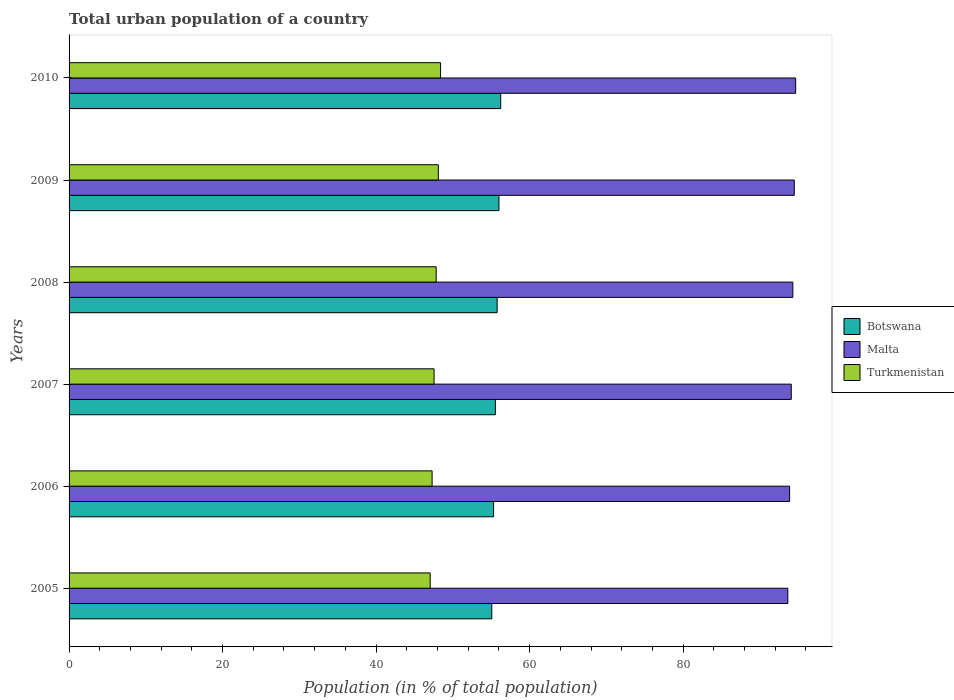How many different coloured bars are there?
Give a very brief answer. 3. How many groups of bars are there?
Your answer should be compact. 6. Are the number of bars on each tick of the Y-axis equal?
Give a very brief answer. Yes. How many bars are there on the 1st tick from the top?
Your answer should be very brief. 3. What is the label of the 2nd group of bars from the top?
Your answer should be compact. 2009. In how many cases, is the number of bars for a given year not equal to the number of legend labels?
Give a very brief answer. 0. What is the urban population in Turkmenistan in 2006?
Give a very brief answer. 47.3. Across all years, what is the maximum urban population in Malta?
Provide a succinct answer. 94.67. Across all years, what is the minimum urban population in Malta?
Provide a succinct answer. 93.64. In which year was the urban population in Turkmenistan maximum?
Your answer should be very brief. 2010. What is the total urban population in Malta in the graph?
Give a very brief answer. 565.06. What is the difference between the urban population in Malta in 2005 and that in 2006?
Make the answer very short. -0.23. What is the difference between the urban population in Botswana in 2006 and the urban population in Turkmenistan in 2009?
Your answer should be compact. 7.2. What is the average urban population in Malta per year?
Provide a short and direct response. 94.18. In the year 2009, what is the difference between the urban population in Turkmenistan and urban population in Malta?
Provide a short and direct response. -46.38. What is the ratio of the urban population in Malta in 2007 to that in 2010?
Ensure brevity in your answer.  0.99. Is the difference between the urban population in Turkmenistan in 2007 and 2008 greater than the difference between the urban population in Malta in 2007 and 2008?
Your answer should be compact. No. What is the difference between the highest and the second highest urban population in Malta?
Provide a short and direct response. 0.18. What is the difference between the highest and the lowest urban population in Turkmenistan?
Your answer should be very brief. 1.35. What does the 3rd bar from the top in 2006 represents?
Ensure brevity in your answer.  Botswana. What does the 1st bar from the bottom in 2007 represents?
Your answer should be very brief. Botswana. How many bars are there?
Offer a terse response. 18. Are the values on the major ticks of X-axis written in scientific E-notation?
Provide a succinct answer. No. Does the graph contain any zero values?
Your answer should be very brief. No. Does the graph contain grids?
Your response must be concise. No. What is the title of the graph?
Provide a short and direct response. Total urban population of a country. What is the label or title of the X-axis?
Your answer should be compact. Population (in % of total population). What is the Population (in % of total population) of Botswana in 2005?
Your answer should be compact. 55.07. What is the Population (in % of total population) of Malta in 2005?
Ensure brevity in your answer.  93.64. What is the Population (in % of total population) of Turkmenistan in 2005?
Keep it short and to the point. 47.05. What is the Population (in % of total population) in Botswana in 2006?
Your response must be concise. 55.31. What is the Population (in % of total population) in Malta in 2006?
Keep it short and to the point. 93.88. What is the Population (in % of total population) in Turkmenistan in 2006?
Offer a terse response. 47.3. What is the Population (in % of total population) in Botswana in 2007?
Your answer should be very brief. 55.54. What is the Population (in % of total population) of Malta in 2007?
Provide a short and direct response. 94.09. What is the Population (in % of total population) of Turkmenistan in 2007?
Ensure brevity in your answer.  47.55. What is the Population (in % of total population) of Botswana in 2008?
Offer a very short reply. 55.77. What is the Population (in % of total population) of Malta in 2008?
Keep it short and to the point. 94.3. What is the Population (in % of total population) of Turkmenistan in 2008?
Your response must be concise. 47.83. What is the Population (in % of total population) of Botswana in 2009?
Offer a very short reply. 56. What is the Population (in % of total population) in Malta in 2009?
Provide a succinct answer. 94.49. What is the Population (in % of total population) of Turkmenistan in 2009?
Keep it short and to the point. 48.11. What is the Population (in % of total population) of Botswana in 2010?
Give a very brief answer. 56.23. What is the Population (in % of total population) of Malta in 2010?
Your answer should be very brief. 94.67. What is the Population (in % of total population) in Turkmenistan in 2010?
Your response must be concise. 48.4. Across all years, what is the maximum Population (in % of total population) in Botswana?
Provide a succinct answer. 56.23. Across all years, what is the maximum Population (in % of total population) in Malta?
Your response must be concise. 94.67. Across all years, what is the maximum Population (in % of total population) of Turkmenistan?
Offer a very short reply. 48.4. Across all years, what is the minimum Population (in % of total population) in Botswana?
Provide a short and direct response. 55.07. Across all years, what is the minimum Population (in % of total population) of Malta?
Provide a succinct answer. 93.64. Across all years, what is the minimum Population (in % of total population) in Turkmenistan?
Your answer should be compact. 47.05. What is the total Population (in % of total population) of Botswana in the graph?
Keep it short and to the point. 333.93. What is the total Population (in % of total population) in Malta in the graph?
Keep it short and to the point. 565.06. What is the total Population (in % of total population) of Turkmenistan in the graph?
Provide a short and direct response. 286.24. What is the difference between the Population (in % of total population) in Botswana in 2005 and that in 2006?
Provide a succinct answer. -0.23. What is the difference between the Population (in % of total population) of Malta in 2005 and that in 2006?
Offer a terse response. -0.23. What is the difference between the Population (in % of total population) of Turkmenistan in 2005 and that in 2006?
Provide a succinct answer. -0.25. What is the difference between the Population (in % of total population) in Botswana in 2005 and that in 2007?
Offer a very short reply. -0.47. What is the difference between the Population (in % of total population) of Malta in 2005 and that in 2007?
Offer a terse response. -0.45. What is the difference between the Population (in % of total population) in Turkmenistan in 2005 and that in 2007?
Keep it short and to the point. -0.51. What is the difference between the Population (in % of total population) in Botswana in 2005 and that in 2008?
Ensure brevity in your answer.  -0.7. What is the difference between the Population (in % of total population) of Malta in 2005 and that in 2008?
Offer a terse response. -0.65. What is the difference between the Population (in % of total population) of Turkmenistan in 2005 and that in 2008?
Provide a succinct answer. -0.78. What is the difference between the Population (in % of total population) of Botswana in 2005 and that in 2009?
Offer a terse response. -0.93. What is the difference between the Population (in % of total population) in Malta in 2005 and that in 2009?
Ensure brevity in your answer.  -0.84. What is the difference between the Population (in % of total population) in Turkmenistan in 2005 and that in 2009?
Provide a succinct answer. -1.06. What is the difference between the Population (in % of total population) of Botswana in 2005 and that in 2010?
Your response must be concise. -1.16. What is the difference between the Population (in % of total population) in Malta in 2005 and that in 2010?
Make the answer very short. -1.02. What is the difference between the Population (in % of total population) in Turkmenistan in 2005 and that in 2010?
Make the answer very short. -1.35. What is the difference between the Population (in % of total population) in Botswana in 2006 and that in 2007?
Your response must be concise. -0.23. What is the difference between the Population (in % of total population) of Malta in 2006 and that in 2007?
Provide a short and direct response. -0.22. What is the difference between the Population (in % of total population) in Turkmenistan in 2006 and that in 2007?
Offer a terse response. -0.26. What is the difference between the Population (in % of total population) in Botswana in 2006 and that in 2008?
Ensure brevity in your answer.  -0.47. What is the difference between the Population (in % of total population) of Malta in 2006 and that in 2008?
Your response must be concise. -0.42. What is the difference between the Population (in % of total population) of Turkmenistan in 2006 and that in 2008?
Provide a short and direct response. -0.53. What is the difference between the Population (in % of total population) of Botswana in 2006 and that in 2009?
Provide a short and direct response. -0.7. What is the difference between the Population (in % of total population) in Malta in 2006 and that in 2009?
Offer a terse response. -0.61. What is the difference between the Population (in % of total population) in Turkmenistan in 2006 and that in 2009?
Ensure brevity in your answer.  -0.81. What is the difference between the Population (in % of total population) in Botswana in 2006 and that in 2010?
Ensure brevity in your answer.  -0.93. What is the difference between the Population (in % of total population) in Malta in 2006 and that in 2010?
Your answer should be very brief. -0.79. What is the difference between the Population (in % of total population) of Turkmenistan in 2006 and that in 2010?
Your answer should be compact. -1.11. What is the difference between the Population (in % of total population) of Botswana in 2007 and that in 2008?
Offer a terse response. -0.23. What is the difference between the Population (in % of total population) in Malta in 2007 and that in 2008?
Keep it short and to the point. -0.2. What is the difference between the Population (in % of total population) in Turkmenistan in 2007 and that in 2008?
Provide a succinct answer. -0.27. What is the difference between the Population (in % of total population) of Botswana in 2007 and that in 2009?
Ensure brevity in your answer.  -0.47. What is the difference between the Population (in % of total population) in Malta in 2007 and that in 2009?
Your answer should be very brief. -0.39. What is the difference between the Population (in % of total population) in Turkmenistan in 2007 and that in 2009?
Offer a very short reply. -0.55. What is the difference between the Population (in % of total population) of Botswana in 2007 and that in 2010?
Keep it short and to the point. -0.7. What is the difference between the Population (in % of total population) in Malta in 2007 and that in 2010?
Offer a terse response. -0.57. What is the difference between the Population (in % of total population) of Turkmenistan in 2007 and that in 2010?
Keep it short and to the point. -0.85. What is the difference between the Population (in % of total population) of Botswana in 2008 and that in 2009?
Your answer should be very brief. -0.23. What is the difference between the Population (in % of total population) in Malta in 2008 and that in 2009?
Keep it short and to the point. -0.19. What is the difference between the Population (in % of total population) in Turkmenistan in 2008 and that in 2009?
Provide a succinct answer. -0.28. What is the difference between the Population (in % of total population) in Botswana in 2008 and that in 2010?
Your response must be concise. -0.46. What is the difference between the Population (in % of total population) in Malta in 2008 and that in 2010?
Your answer should be compact. -0.37. What is the difference between the Population (in % of total population) in Turkmenistan in 2008 and that in 2010?
Give a very brief answer. -0.58. What is the difference between the Population (in % of total population) of Botswana in 2009 and that in 2010?
Make the answer very short. -0.23. What is the difference between the Population (in % of total population) of Malta in 2009 and that in 2010?
Your answer should be compact. -0.18. What is the difference between the Population (in % of total population) in Turkmenistan in 2009 and that in 2010?
Ensure brevity in your answer.  -0.29. What is the difference between the Population (in % of total population) of Botswana in 2005 and the Population (in % of total population) of Malta in 2006?
Offer a terse response. -38.8. What is the difference between the Population (in % of total population) in Botswana in 2005 and the Population (in % of total population) in Turkmenistan in 2006?
Offer a very short reply. 7.78. What is the difference between the Population (in % of total population) in Malta in 2005 and the Population (in % of total population) in Turkmenistan in 2006?
Provide a succinct answer. 46.35. What is the difference between the Population (in % of total population) in Botswana in 2005 and the Population (in % of total population) in Malta in 2007?
Keep it short and to the point. -39.02. What is the difference between the Population (in % of total population) of Botswana in 2005 and the Population (in % of total population) of Turkmenistan in 2007?
Keep it short and to the point. 7.52. What is the difference between the Population (in % of total population) in Malta in 2005 and the Population (in % of total population) in Turkmenistan in 2007?
Make the answer very short. 46.09. What is the difference between the Population (in % of total population) of Botswana in 2005 and the Population (in % of total population) of Malta in 2008?
Offer a terse response. -39.22. What is the difference between the Population (in % of total population) in Botswana in 2005 and the Population (in % of total population) in Turkmenistan in 2008?
Provide a short and direct response. 7.25. What is the difference between the Population (in % of total population) in Malta in 2005 and the Population (in % of total population) in Turkmenistan in 2008?
Give a very brief answer. 45.82. What is the difference between the Population (in % of total population) in Botswana in 2005 and the Population (in % of total population) in Malta in 2009?
Provide a succinct answer. -39.41. What is the difference between the Population (in % of total population) of Botswana in 2005 and the Population (in % of total population) of Turkmenistan in 2009?
Give a very brief answer. 6.96. What is the difference between the Population (in % of total population) in Malta in 2005 and the Population (in % of total population) in Turkmenistan in 2009?
Your response must be concise. 45.54. What is the difference between the Population (in % of total population) in Botswana in 2005 and the Population (in % of total population) in Malta in 2010?
Offer a terse response. -39.59. What is the difference between the Population (in % of total population) in Botswana in 2005 and the Population (in % of total population) in Turkmenistan in 2010?
Offer a very short reply. 6.67. What is the difference between the Population (in % of total population) of Malta in 2005 and the Population (in % of total population) of Turkmenistan in 2010?
Provide a short and direct response. 45.24. What is the difference between the Population (in % of total population) in Botswana in 2006 and the Population (in % of total population) in Malta in 2007?
Offer a very short reply. -38.79. What is the difference between the Population (in % of total population) of Botswana in 2006 and the Population (in % of total population) of Turkmenistan in 2007?
Your answer should be very brief. 7.75. What is the difference between the Population (in % of total population) of Malta in 2006 and the Population (in % of total population) of Turkmenistan in 2007?
Provide a succinct answer. 46.32. What is the difference between the Population (in % of total population) in Botswana in 2006 and the Population (in % of total population) in Malta in 2008?
Your answer should be compact. -38.99. What is the difference between the Population (in % of total population) of Botswana in 2006 and the Population (in % of total population) of Turkmenistan in 2008?
Provide a short and direct response. 7.48. What is the difference between the Population (in % of total population) of Malta in 2006 and the Population (in % of total population) of Turkmenistan in 2008?
Make the answer very short. 46.05. What is the difference between the Population (in % of total population) of Botswana in 2006 and the Population (in % of total population) of Malta in 2009?
Provide a succinct answer. -39.18. What is the difference between the Population (in % of total population) of Botswana in 2006 and the Population (in % of total population) of Turkmenistan in 2009?
Keep it short and to the point. 7.2. What is the difference between the Population (in % of total population) of Malta in 2006 and the Population (in % of total population) of Turkmenistan in 2009?
Provide a succinct answer. 45.77. What is the difference between the Population (in % of total population) of Botswana in 2006 and the Population (in % of total population) of Malta in 2010?
Your response must be concise. -39.36. What is the difference between the Population (in % of total population) in Botswana in 2006 and the Population (in % of total population) in Turkmenistan in 2010?
Give a very brief answer. 6.9. What is the difference between the Population (in % of total population) in Malta in 2006 and the Population (in % of total population) in Turkmenistan in 2010?
Keep it short and to the point. 45.47. What is the difference between the Population (in % of total population) of Botswana in 2007 and the Population (in % of total population) of Malta in 2008?
Offer a very short reply. -38.76. What is the difference between the Population (in % of total population) in Botswana in 2007 and the Population (in % of total population) in Turkmenistan in 2008?
Provide a succinct answer. 7.71. What is the difference between the Population (in % of total population) of Malta in 2007 and the Population (in % of total population) of Turkmenistan in 2008?
Your response must be concise. 46.27. What is the difference between the Population (in % of total population) in Botswana in 2007 and the Population (in % of total population) in Malta in 2009?
Provide a short and direct response. -38.95. What is the difference between the Population (in % of total population) of Botswana in 2007 and the Population (in % of total population) of Turkmenistan in 2009?
Give a very brief answer. 7.43. What is the difference between the Population (in % of total population) in Malta in 2007 and the Population (in % of total population) in Turkmenistan in 2009?
Offer a very short reply. 45.98. What is the difference between the Population (in % of total population) of Botswana in 2007 and the Population (in % of total population) of Malta in 2010?
Offer a very short reply. -39.13. What is the difference between the Population (in % of total population) of Botswana in 2007 and the Population (in % of total population) of Turkmenistan in 2010?
Offer a terse response. 7.14. What is the difference between the Population (in % of total population) in Malta in 2007 and the Population (in % of total population) in Turkmenistan in 2010?
Give a very brief answer. 45.69. What is the difference between the Population (in % of total population) of Botswana in 2008 and the Population (in % of total population) of Malta in 2009?
Provide a succinct answer. -38.71. What is the difference between the Population (in % of total population) of Botswana in 2008 and the Population (in % of total population) of Turkmenistan in 2009?
Give a very brief answer. 7.66. What is the difference between the Population (in % of total population) of Malta in 2008 and the Population (in % of total population) of Turkmenistan in 2009?
Provide a succinct answer. 46.19. What is the difference between the Population (in % of total population) of Botswana in 2008 and the Population (in % of total population) of Malta in 2010?
Ensure brevity in your answer.  -38.89. What is the difference between the Population (in % of total population) of Botswana in 2008 and the Population (in % of total population) of Turkmenistan in 2010?
Provide a succinct answer. 7.37. What is the difference between the Population (in % of total population) in Malta in 2008 and the Population (in % of total population) in Turkmenistan in 2010?
Ensure brevity in your answer.  45.89. What is the difference between the Population (in % of total population) of Botswana in 2009 and the Population (in % of total population) of Malta in 2010?
Your answer should be compact. -38.66. What is the difference between the Population (in % of total population) of Botswana in 2009 and the Population (in % of total population) of Turkmenistan in 2010?
Provide a short and direct response. 7.6. What is the difference between the Population (in % of total population) in Malta in 2009 and the Population (in % of total population) in Turkmenistan in 2010?
Ensure brevity in your answer.  46.08. What is the average Population (in % of total population) of Botswana per year?
Keep it short and to the point. 55.65. What is the average Population (in % of total population) of Malta per year?
Ensure brevity in your answer.  94.18. What is the average Population (in % of total population) of Turkmenistan per year?
Ensure brevity in your answer.  47.71. In the year 2005, what is the difference between the Population (in % of total population) in Botswana and Population (in % of total population) in Malta?
Offer a terse response. -38.57. In the year 2005, what is the difference between the Population (in % of total population) in Botswana and Population (in % of total population) in Turkmenistan?
Your response must be concise. 8.03. In the year 2005, what is the difference between the Population (in % of total population) of Malta and Population (in % of total population) of Turkmenistan?
Provide a short and direct response. 46.6. In the year 2006, what is the difference between the Population (in % of total population) in Botswana and Population (in % of total population) in Malta?
Make the answer very short. -38.57. In the year 2006, what is the difference between the Population (in % of total population) of Botswana and Population (in % of total population) of Turkmenistan?
Provide a short and direct response. 8.01. In the year 2006, what is the difference between the Population (in % of total population) in Malta and Population (in % of total population) in Turkmenistan?
Offer a very short reply. 46.58. In the year 2007, what is the difference between the Population (in % of total population) in Botswana and Population (in % of total population) in Malta?
Offer a very short reply. -38.55. In the year 2007, what is the difference between the Population (in % of total population) in Botswana and Population (in % of total population) in Turkmenistan?
Your response must be concise. 7.98. In the year 2007, what is the difference between the Population (in % of total population) in Malta and Population (in % of total population) in Turkmenistan?
Keep it short and to the point. 46.54. In the year 2008, what is the difference between the Population (in % of total population) of Botswana and Population (in % of total population) of Malta?
Give a very brief answer. -38.52. In the year 2008, what is the difference between the Population (in % of total population) in Botswana and Population (in % of total population) in Turkmenistan?
Offer a terse response. 7.95. In the year 2008, what is the difference between the Population (in % of total population) in Malta and Population (in % of total population) in Turkmenistan?
Offer a terse response. 46.47. In the year 2009, what is the difference between the Population (in % of total population) of Botswana and Population (in % of total population) of Malta?
Your answer should be compact. -38.48. In the year 2009, what is the difference between the Population (in % of total population) in Botswana and Population (in % of total population) in Turkmenistan?
Offer a terse response. 7.89. In the year 2009, what is the difference between the Population (in % of total population) in Malta and Population (in % of total population) in Turkmenistan?
Your answer should be very brief. 46.38. In the year 2010, what is the difference between the Population (in % of total population) of Botswana and Population (in % of total population) of Malta?
Make the answer very short. -38.43. In the year 2010, what is the difference between the Population (in % of total population) in Botswana and Population (in % of total population) in Turkmenistan?
Give a very brief answer. 7.83. In the year 2010, what is the difference between the Population (in % of total population) in Malta and Population (in % of total population) in Turkmenistan?
Provide a succinct answer. 46.26. What is the ratio of the Population (in % of total population) of Botswana in 2005 to that in 2006?
Offer a very short reply. 1. What is the ratio of the Population (in % of total population) of Malta in 2005 to that in 2006?
Offer a very short reply. 1. What is the ratio of the Population (in % of total population) in Turkmenistan in 2005 to that in 2006?
Ensure brevity in your answer.  0.99. What is the ratio of the Population (in % of total population) of Turkmenistan in 2005 to that in 2007?
Provide a succinct answer. 0.99. What is the ratio of the Population (in % of total population) of Botswana in 2005 to that in 2008?
Provide a short and direct response. 0.99. What is the ratio of the Population (in % of total population) in Turkmenistan in 2005 to that in 2008?
Give a very brief answer. 0.98. What is the ratio of the Population (in % of total population) in Botswana in 2005 to that in 2009?
Give a very brief answer. 0.98. What is the ratio of the Population (in % of total population) in Malta in 2005 to that in 2009?
Give a very brief answer. 0.99. What is the ratio of the Population (in % of total population) of Turkmenistan in 2005 to that in 2009?
Your answer should be compact. 0.98. What is the ratio of the Population (in % of total population) of Botswana in 2005 to that in 2010?
Provide a short and direct response. 0.98. What is the ratio of the Population (in % of total population) in Malta in 2005 to that in 2010?
Provide a succinct answer. 0.99. What is the ratio of the Population (in % of total population) of Botswana in 2006 to that in 2007?
Your response must be concise. 1. What is the ratio of the Population (in % of total population) in Turkmenistan in 2006 to that in 2007?
Ensure brevity in your answer.  0.99. What is the ratio of the Population (in % of total population) in Botswana in 2006 to that in 2008?
Ensure brevity in your answer.  0.99. What is the ratio of the Population (in % of total population) in Malta in 2006 to that in 2008?
Provide a succinct answer. 1. What is the ratio of the Population (in % of total population) in Turkmenistan in 2006 to that in 2008?
Offer a very short reply. 0.99. What is the ratio of the Population (in % of total population) of Botswana in 2006 to that in 2009?
Offer a very short reply. 0.99. What is the ratio of the Population (in % of total population) of Turkmenistan in 2006 to that in 2009?
Offer a terse response. 0.98. What is the ratio of the Population (in % of total population) of Botswana in 2006 to that in 2010?
Your answer should be very brief. 0.98. What is the ratio of the Population (in % of total population) of Malta in 2006 to that in 2010?
Make the answer very short. 0.99. What is the ratio of the Population (in % of total population) of Turkmenistan in 2006 to that in 2010?
Offer a very short reply. 0.98. What is the ratio of the Population (in % of total population) in Malta in 2007 to that in 2008?
Ensure brevity in your answer.  1. What is the ratio of the Population (in % of total population) in Turkmenistan in 2007 to that in 2008?
Your answer should be very brief. 0.99. What is the ratio of the Population (in % of total population) of Turkmenistan in 2007 to that in 2009?
Provide a succinct answer. 0.99. What is the ratio of the Population (in % of total population) in Botswana in 2007 to that in 2010?
Your answer should be compact. 0.99. What is the ratio of the Population (in % of total population) in Malta in 2007 to that in 2010?
Make the answer very short. 0.99. What is the ratio of the Population (in % of total population) in Turkmenistan in 2007 to that in 2010?
Offer a very short reply. 0.98. What is the ratio of the Population (in % of total population) in Botswana in 2008 to that in 2009?
Your answer should be very brief. 1. What is the ratio of the Population (in % of total population) in Turkmenistan in 2008 to that in 2009?
Give a very brief answer. 0.99. What is the ratio of the Population (in % of total population) in Botswana in 2008 to that in 2010?
Keep it short and to the point. 0.99. What is the ratio of the Population (in % of total population) in Malta in 2008 to that in 2010?
Provide a succinct answer. 1. What is the ratio of the Population (in % of total population) in Botswana in 2009 to that in 2010?
Make the answer very short. 1. What is the difference between the highest and the second highest Population (in % of total population) in Botswana?
Make the answer very short. 0.23. What is the difference between the highest and the second highest Population (in % of total population) of Malta?
Ensure brevity in your answer.  0.18. What is the difference between the highest and the second highest Population (in % of total population) in Turkmenistan?
Your answer should be compact. 0.29. What is the difference between the highest and the lowest Population (in % of total population) in Botswana?
Give a very brief answer. 1.16. What is the difference between the highest and the lowest Population (in % of total population) in Turkmenistan?
Your answer should be compact. 1.35. 